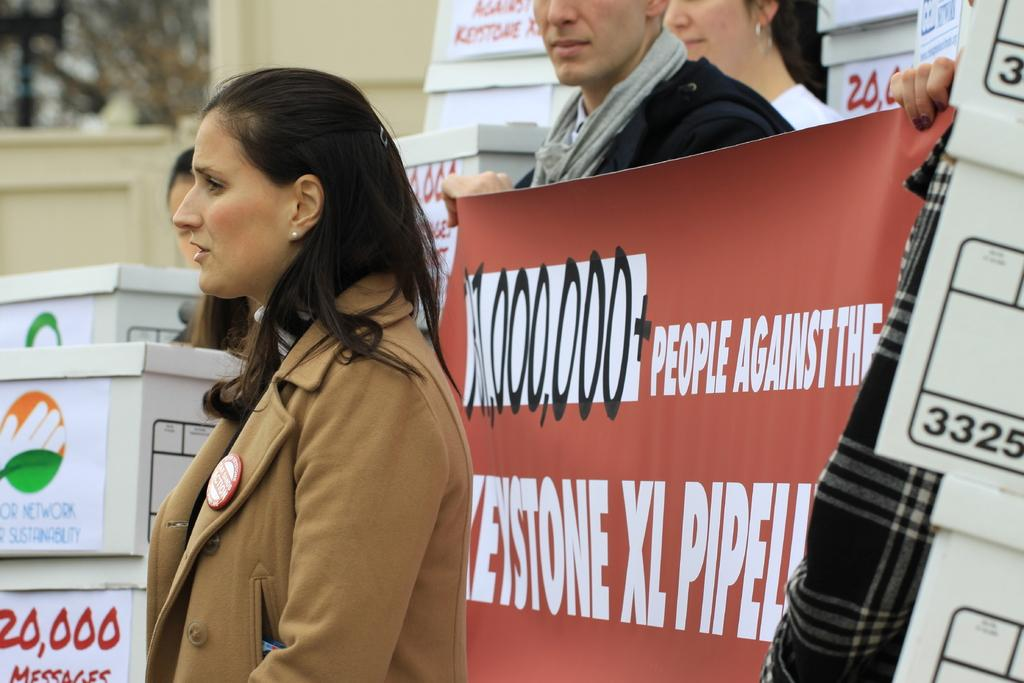What are the people in the image wearing? The people in the image are wearing different color dresses. What objects can be seen in the image besides the people? There are boxes in the image, and stickers are attached to the boxes. What are two people doing in the image? Two people are holding a banner in the image. What type of tools does the carpenter use in the image? There is no carpenter present in the image, so it is not possible to determine what tools they might use. 